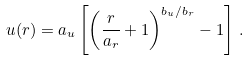Convert formula to latex. <formula><loc_0><loc_0><loc_500><loc_500>u ( r ) = a _ { u } \left [ \left ( \frac { r } { a _ { r } } + 1 \right ) ^ { b _ { u } / b _ { r } } - 1 \right ] \, .</formula> 